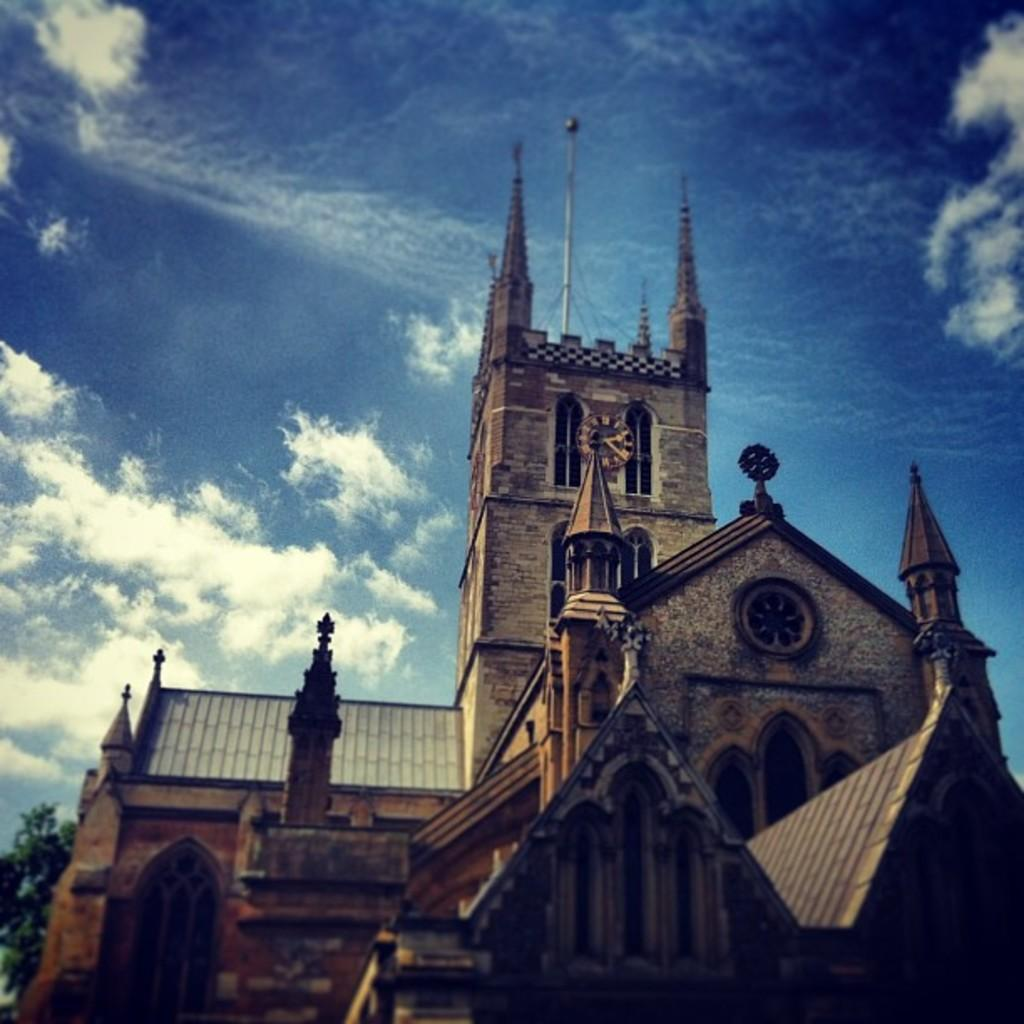What type of structure is present in the image? There is a building in the image. Can you describe the color of the building? The building is brown in color. What can be seen on the left side of the image? There are trees on the left side of the image. What is visible in the sky in the background of the image? There are clouds visible in the sky in the background of the image. Where is the bag of berries located in the image? There is no bag of berries present in the image. What type of channel can be seen in the image? There is no channel present in the image. 